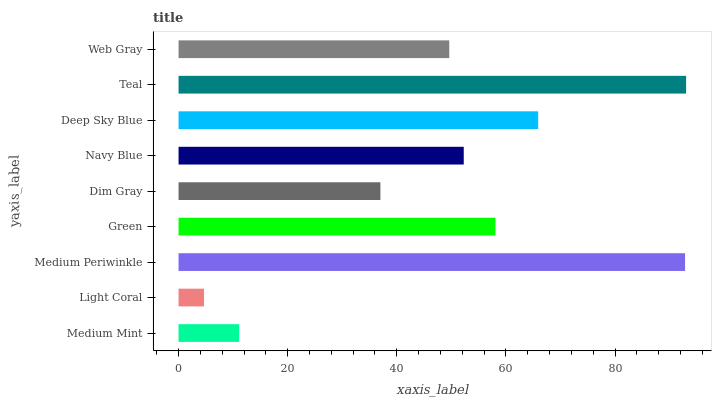Is Light Coral the minimum?
Answer yes or no. Yes. Is Teal the maximum?
Answer yes or no. Yes. Is Medium Periwinkle the minimum?
Answer yes or no. No. Is Medium Periwinkle the maximum?
Answer yes or no. No. Is Medium Periwinkle greater than Light Coral?
Answer yes or no. Yes. Is Light Coral less than Medium Periwinkle?
Answer yes or no. Yes. Is Light Coral greater than Medium Periwinkle?
Answer yes or no. No. Is Medium Periwinkle less than Light Coral?
Answer yes or no. No. Is Navy Blue the high median?
Answer yes or no. Yes. Is Navy Blue the low median?
Answer yes or no. Yes. Is Green the high median?
Answer yes or no. No. Is Teal the low median?
Answer yes or no. No. 